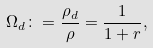Convert formula to latex. <formula><loc_0><loc_0><loc_500><loc_500>\Omega _ { d } \colon = \frac { \rho _ { d } } { \rho } = \frac { 1 } { 1 + r } ,</formula> 